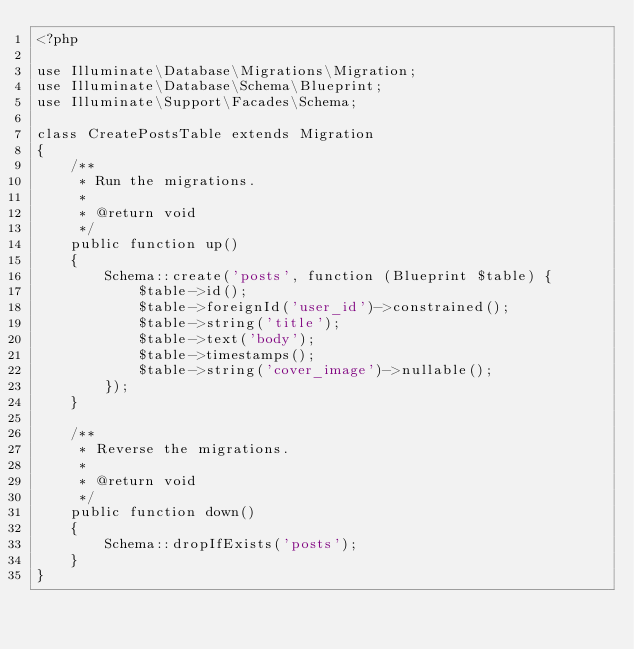<code> <loc_0><loc_0><loc_500><loc_500><_PHP_><?php

use Illuminate\Database\Migrations\Migration;
use Illuminate\Database\Schema\Blueprint;
use Illuminate\Support\Facades\Schema;

class CreatePostsTable extends Migration
{
    /**
     * Run the migrations.
     *
     * @return void
     */
    public function up()
    {
        Schema::create('posts', function (Blueprint $table) {
            $table->id();
            $table->foreignId('user_id')->constrained();
            $table->string('title');
            $table->text('body');
            $table->timestamps();
            $table->string('cover_image')->nullable();
        });
    }

    /**
     * Reverse the migrations.
     *
     * @return void
     */
    public function down()
    {
        Schema::dropIfExists('posts');
    }
}
</code> 